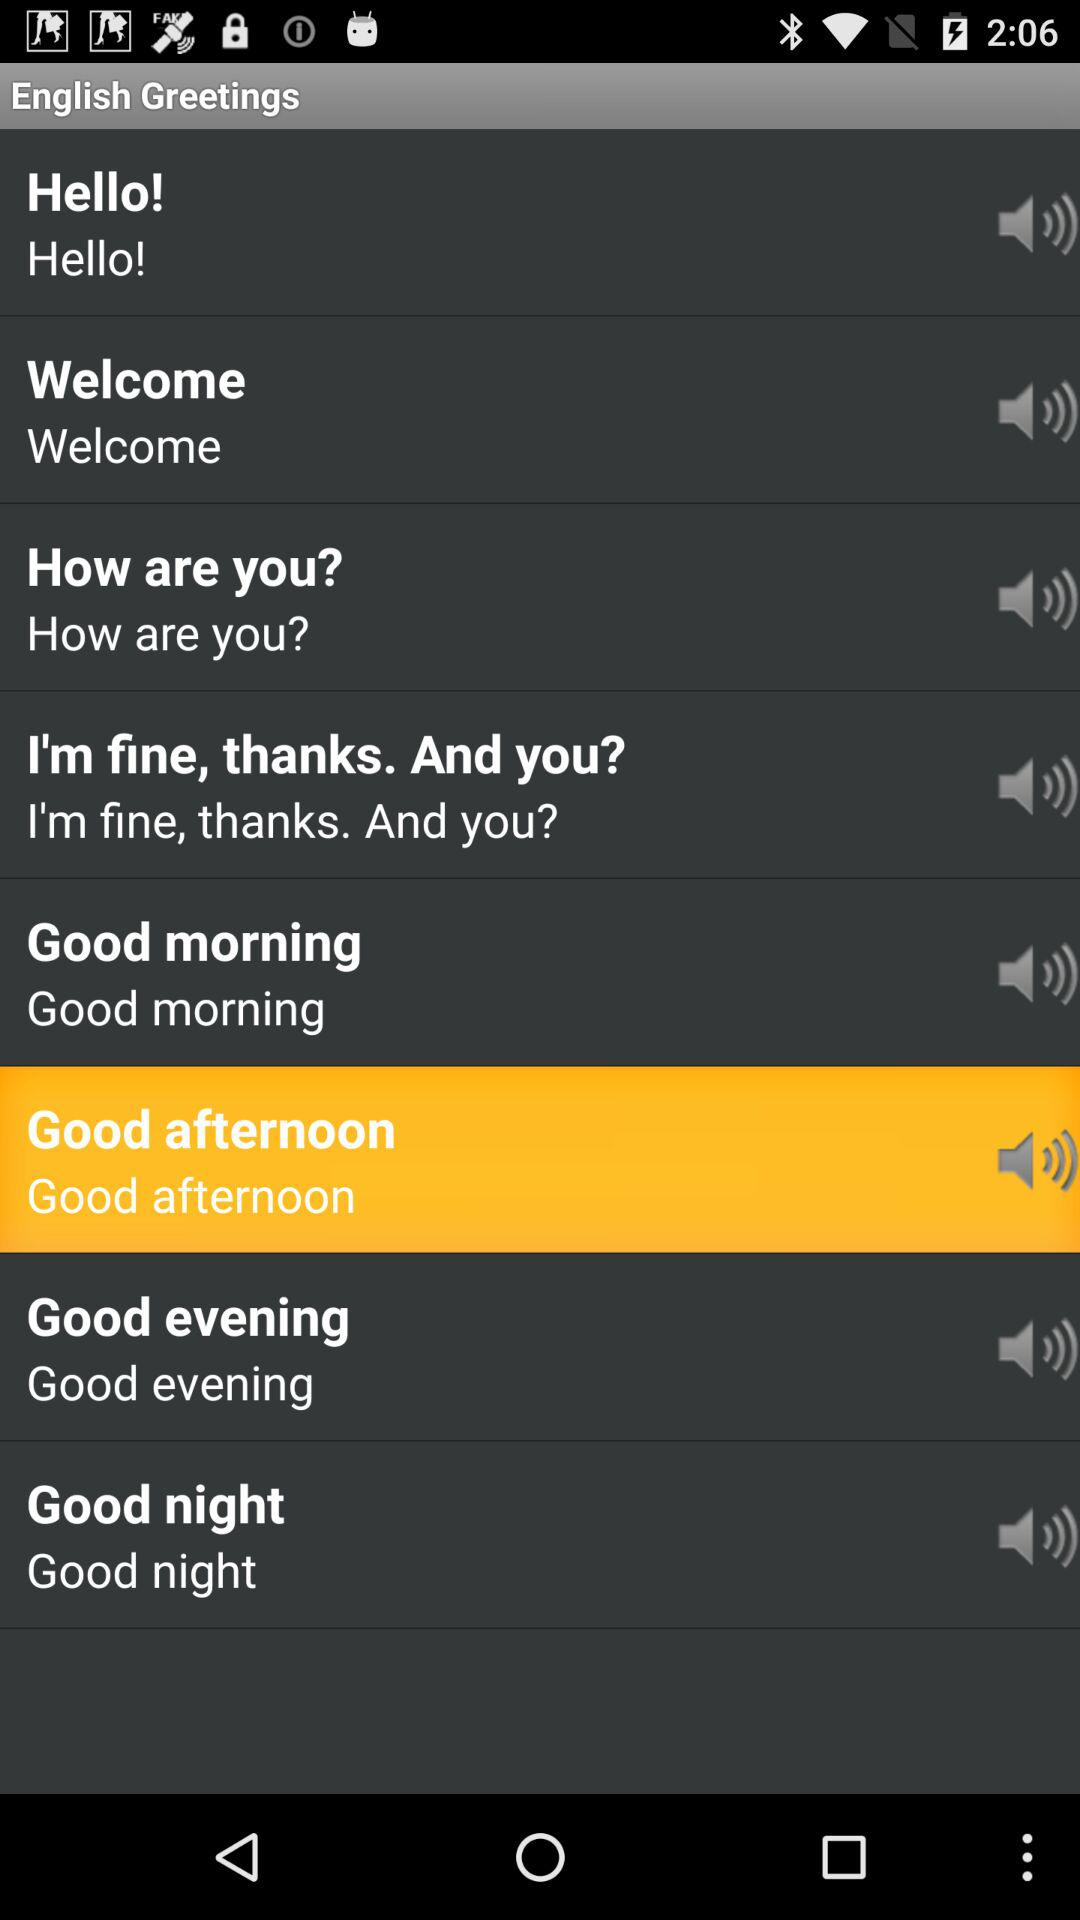Which is the highlighted English greeting? The highlighted English greeting is "Good afternoon". 